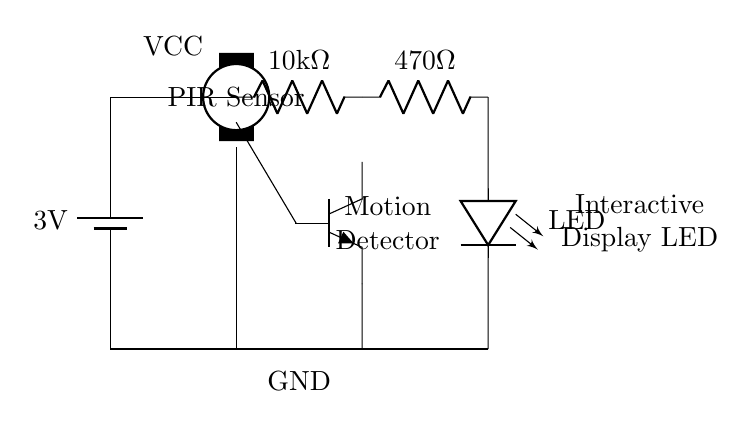What is the power supply voltage in this circuit? The circuit is powered by a battery, as indicated by the battery symbol and the label specifying a voltage of 3 volts.
Answer: 3 volts What type of sensor is used in this circuit? The diagram shows a PIR sensor, identifiable by the label "PIR Sensor" next to it, which is used to detect motion.
Answer: PIR Sensor What component activates the LED? The LED is activated through the PIR sensor's output, which triggers the transistor when motion is detected, allowing current to flow to the LED.
Answer: Transistor What are the resistor values in this circuit? The circuit contains two resistors; one is a 10 kilo-ohm resistor and the other is a 470 ohm resistor, which are labeled next to their respective symbols.
Answer: 10 kilo-ohm and 470 ohm What is the function of the transistor in this circuit? The transistor serves as a switch, allowing the LED to turn on when the PIR sensor detects motion by controlling the flow of electricity to the LED.
Answer: Switch How does the motion detector interact with the LED? When the PIR Sensor detects motion, it sends a signal to the base of the transistor, turning it on and enabling current to flow through to the LED, which lights up.
Answer: It lights up 